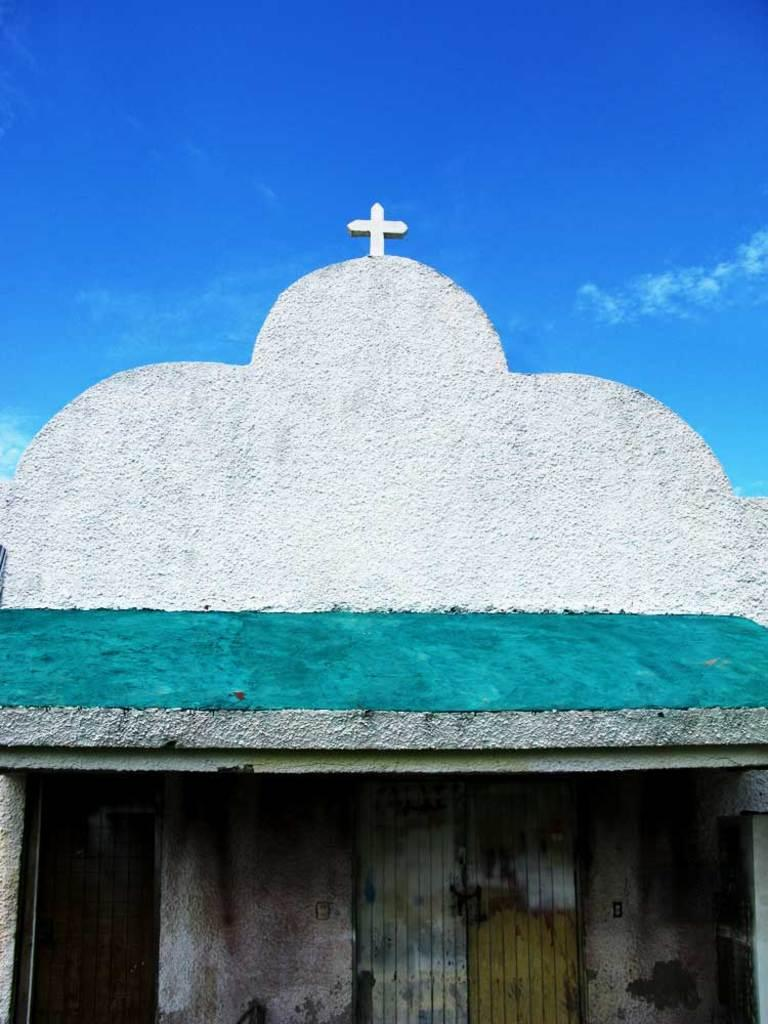What type of structure is present in the image? There is a house in the image. What colors are used for the house? The house is green and white in color. What can be seen in the background of the image? The sky is visible in the background of the image. What is the color of the sky in the image? The sky is blue in color. Where is the toothbrush located in the image? There is no toothbrush present in the image. What type of performance is happening on the stage in the image? There is no stage present in the image. 